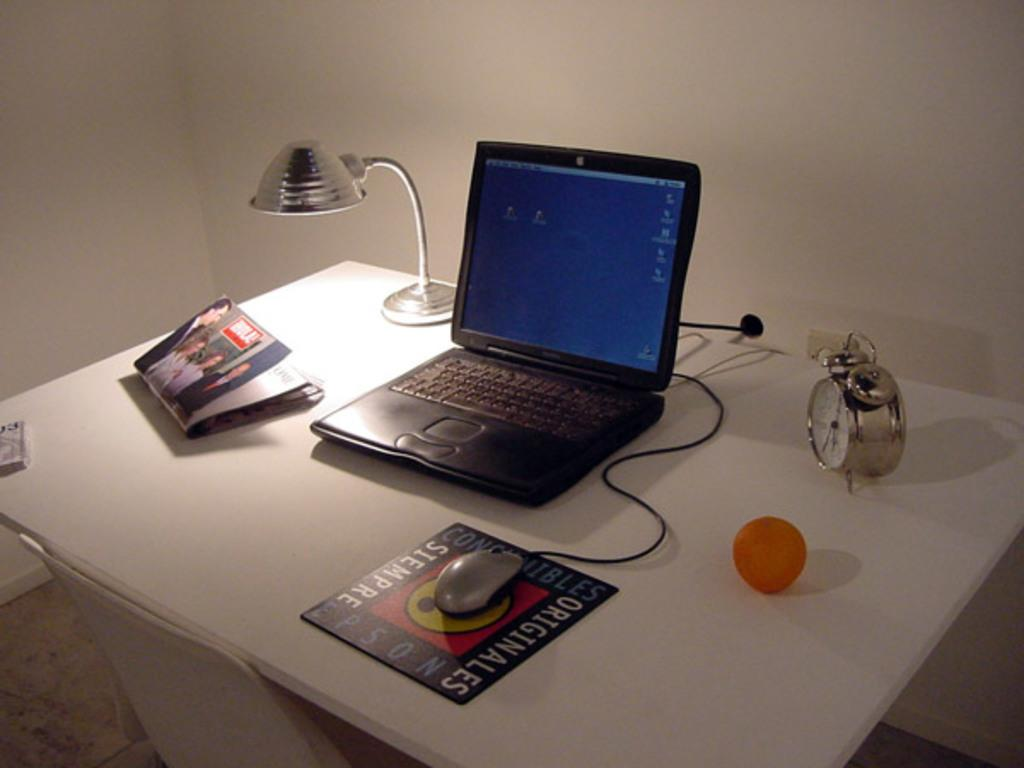What objects are on the table in the image? There is a ball, a clock, a mouse, a laptop, a light, and a book on the table in the image. Can you describe the type of clock on the table? The clock on the table is not described in the facts, so we cannot provide any details about it. What is the purpose of the light on the table? The purpose of the light on the table is not mentioned in the facts, so we cannot determine its purpose. What is the color of the ball on the table? The color of the ball on the table is not mentioned in the facts, so we cannot provide any details about it. How many birds are sitting on the laptop in the image? There are no birds present in the image; it only features a ball, a clock, a mouse, a laptop, a light, and a book on the table. 